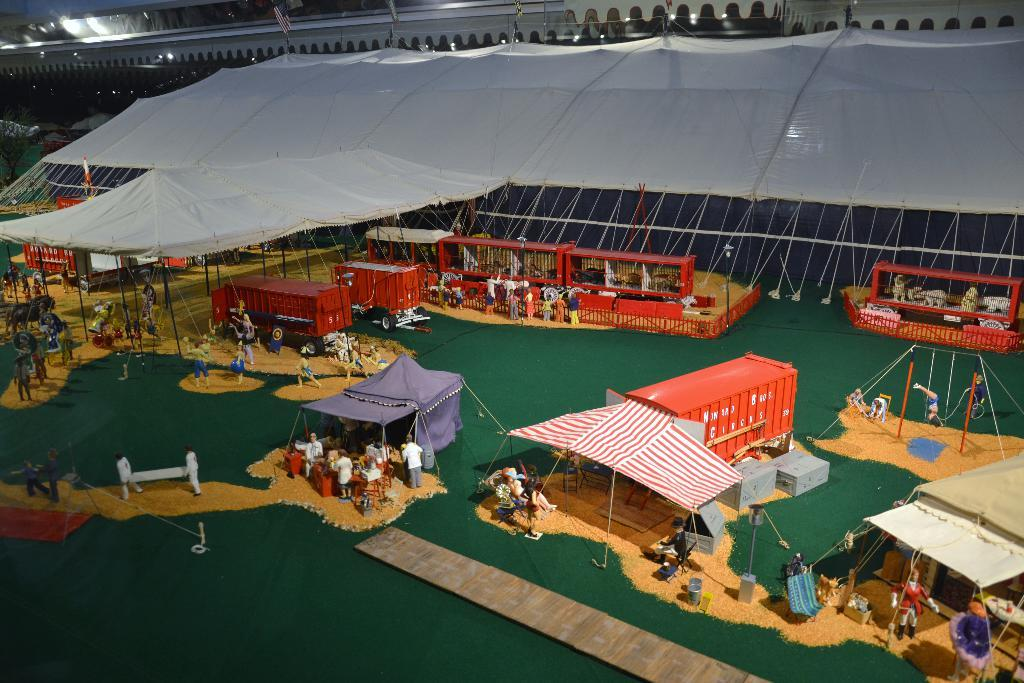What type of temporary shelters can be seen in the image? There are tents in the image. What else is present in the image besides tents? There are vehicles in the image. Can you describe the people in the image? People are standing at the bottom of the image. What additional items can be seen in the image? There are toys visible in the image. What is the limit of the elbow in the image? There is no mention of an elbow in the image, so it is not possible to determine a limit for it. 